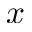Convert formula to latex. <formula><loc_0><loc_0><loc_500><loc_500>x</formula> 